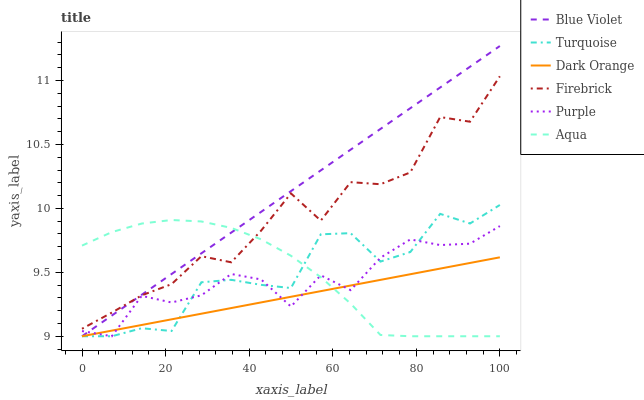Does Turquoise have the minimum area under the curve?
Answer yes or no. No. Does Turquoise have the maximum area under the curve?
Answer yes or no. No. Is Turquoise the smoothest?
Answer yes or no. No. Is Turquoise the roughest?
Answer yes or no. No. Does Firebrick have the lowest value?
Answer yes or no. No. Does Turquoise have the highest value?
Answer yes or no. No. Is Turquoise less than Firebrick?
Answer yes or no. Yes. Is Firebrick greater than Purple?
Answer yes or no. Yes. Does Turquoise intersect Firebrick?
Answer yes or no. No. 